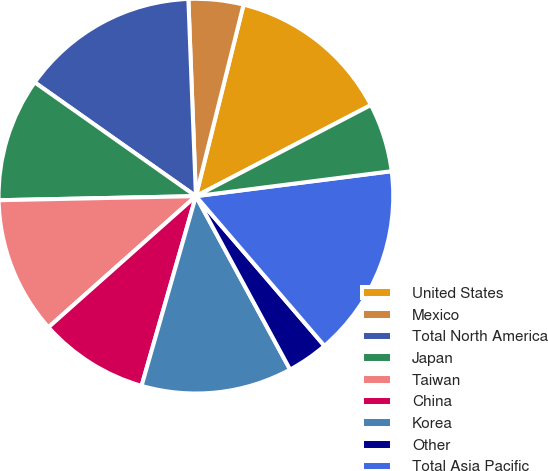Convert chart to OTSL. <chart><loc_0><loc_0><loc_500><loc_500><pie_chart><fcel>United States<fcel>Mexico<fcel>Total North America<fcel>Japan<fcel>Taiwan<fcel>China<fcel>Korea<fcel>Other<fcel>Total Asia Pacific<fcel>Germany<nl><fcel>13.48%<fcel>4.49%<fcel>14.61%<fcel>10.11%<fcel>11.24%<fcel>8.99%<fcel>12.36%<fcel>3.37%<fcel>15.73%<fcel>5.62%<nl></chart> 